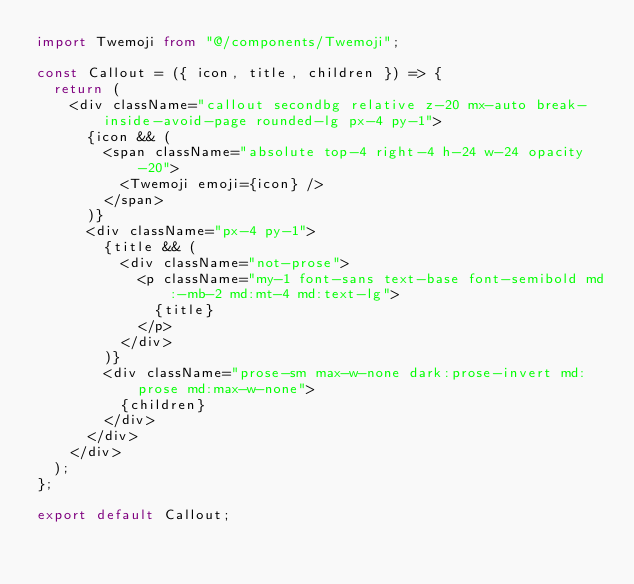Convert code to text. <code><loc_0><loc_0><loc_500><loc_500><_TypeScript_>import Twemoji from "@/components/Twemoji";

const Callout = ({ icon, title, children }) => {
  return (
    <div className="callout secondbg relative z-20 mx-auto break-inside-avoid-page rounded-lg px-4 py-1">
      {icon && (
        <span className="absolute top-4 right-4 h-24 w-24 opacity-20">
          <Twemoji emoji={icon} />
        </span>
      )}
      <div className="px-4 py-1">
        {title && (
          <div className="not-prose">
            <p className="my-1 font-sans text-base font-semibold md:-mb-2 md:mt-4 md:text-lg">
              {title}
            </p>
          </div>
        )}
        <div className="prose-sm max-w-none dark:prose-invert md:prose md:max-w-none">
          {children}
        </div>
      </div>
    </div>
  );
};

export default Callout;
</code> 